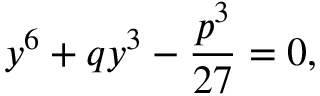Convert formula to latex. <formula><loc_0><loc_0><loc_500><loc_500>y ^ { 6 } + q y ^ { 3 } - \frac { p ^ { 3 } } { 2 7 } = 0 ,</formula> 